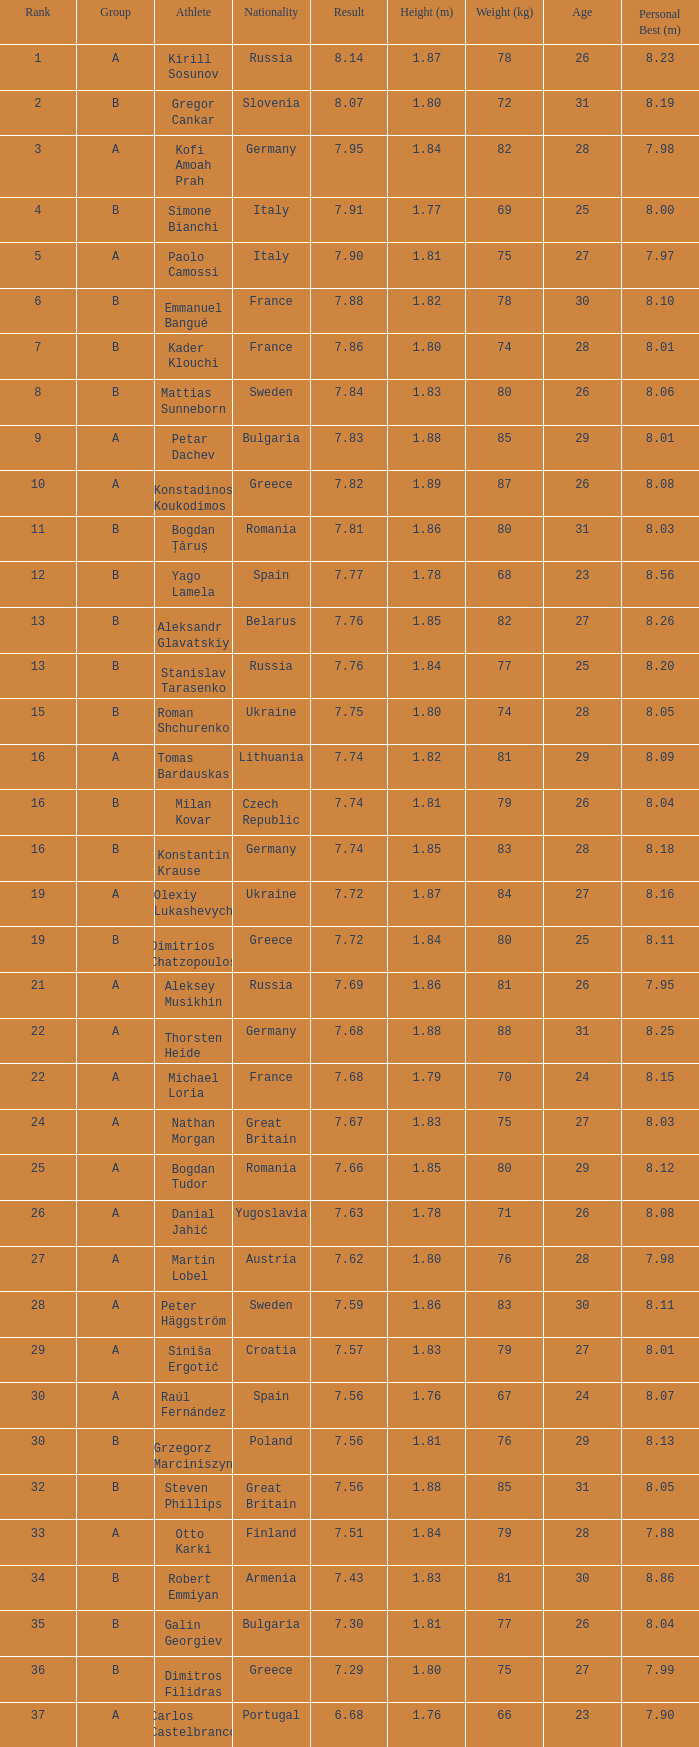Could you help me parse every detail presented in this table? {'header': ['Rank', 'Group', 'Athlete', 'Nationality', 'Result', 'Height (m)', 'Weight (kg)', 'Age', 'Personal Best (m)'], 'rows': [['1', 'A', 'Kirill Sosunov', 'Russia', '8.14', '1.87', '78', '26', '8.23'], ['2', 'B', 'Gregor Cankar', 'Slovenia', '8.07', '1.80', '72', '31', '8.19'], ['3', 'A', 'Kofi Amoah Prah', 'Germany', '7.95', '1.84', '82', '28', '7.98'], ['4', 'B', 'Simone Bianchi', 'Italy', '7.91', '1.77', '69', '25', '8.00'], ['5', 'A', 'Paolo Camossi', 'Italy', '7.90', '1.81', '75', '27', '7.97'], ['6', 'B', 'Emmanuel Bangué', 'France', '7.88', '1.82', '78', '30', '8.10'], ['7', 'B', 'Kader Klouchi', 'France', '7.86', '1.80', '74', '28', '8.01'], ['8', 'B', 'Mattias Sunneborn', 'Sweden', '7.84', '1.83', '80', '26', '8.06'], ['9', 'A', 'Petar Dachev', 'Bulgaria', '7.83', '1.88', '85', '29', '8.01'], ['10', 'A', 'Konstadinos Koukodimos', 'Greece', '7.82', '1.89', '87', '26', '8.08'], ['11', 'B', 'Bogdan Țăruș', 'Romania', '7.81', '1.86', '80', '31', '8.03'], ['12', 'B', 'Yago Lamela', 'Spain', '7.77', '1.78', '68', '23', '8.56'], ['13', 'B', 'Aleksandr Glavatskiy', 'Belarus', '7.76', '1.85', '82', '27', '8.26'], ['13', 'B', 'Stanislav Tarasenko', 'Russia', '7.76', '1.84', '77', '25', '8.20'], ['15', 'B', 'Roman Shchurenko', 'Ukraine', '7.75', '1.80', '74', '28', '8.05'], ['16', 'A', 'Tomas Bardauskas', 'Lithuania', '7.74', '1.82', '81', '29', '8.09'], ['16', 'B', 'Milan Kovar', 'Czech Republic', '7.74', '1.81', '79', '26', '8.04'], ['16', 'B', 'Konstantin Krause', 'Germany', '7.74', '1.85', '83', '28', '8.18'], ['19', 'A', 'Olexiy Lukashevych', 'Ukraine', '7.72', '1.87', '84', '27', '8.16'], ['19', 'B', 'Dimitrios Chatzopoulos', 'Greece', '7.72', '1.84', '80', '25', '8.11'], ['21', 'A', 'Aleksey Musikhin', 'Russia', '7.69', '1.86', '81', '26', '7.95'], ['22', 'A', 'Thorsten Heide', 'Germany', '7.68', '1.88', '88', '31', '8.25'], ['22', 'A', 'Michael Loria', 'France', '7.68', '1.79', '70', '24', '8.15'], ['24', 'A', 'Nathan Morgan', 'Great Britain', '7.67', '1.83', '75', '27', '8.03'], ['25', 'A', 'Bogdan Tudor', 'Romania', '7.66', '1.85', '80', '29', '8.12'], ['26', 'A', 'Danial Jahić', 'Yugoslavia', '7.63', '1.78', '71', '26', '8.08'], ['27', 'A', 'Martin Lobel', 'Austria', '7.62', '1.80', '76', '28', '7.98'], ['28', 'A', 'Peter Häggström', 'Sweden', '7.59', '1.86', '83', '30', '8.11'], ['29', 'A', 'Siniša Ergotić', 'Croatia', '7.57', '1.83', '79', '27', '8.01'], ['30', 'A', 'Raúl Fernández', 'Spain', '7.56', '1.76', '67', '24', '8.07'], ['30', 'B', 'Grzegorz Marciniszyn', 'Poland', '7.56', '1.81', '76', '29', '8.13'], ['32', 'B', 'Steven Phillips', 'Great Britain', '7.56', '1.88', '85', '31', '8.05'], ['33', 'A', 'Otto Karki', 'Finland', '7.51', '1.84', '79', '28', '7.88'], ['34', 'B', 'Robert Emmiyan', 'Armenia', '7.43', '1.83', '81', '30', '8.86'], ['35', 'B', 'Galin Georgiev', 'Bulgaria', '7.30', '1.81', '77', '26', '8.04'], ['36', 'B', 'Dimitros Filidras', 'Greece', '7.29', '1.80', '75', '27', '7.99'], ['37', 'A', 'Carlos Castelbranco', 'Portugal', '6.68', '1.76', '66', '23', '7.90']]} Which athlete's rank is more than 15 when the result is less than 7.68, the group is b, and the nationality listed is Great Britain? Steven Phillips. 